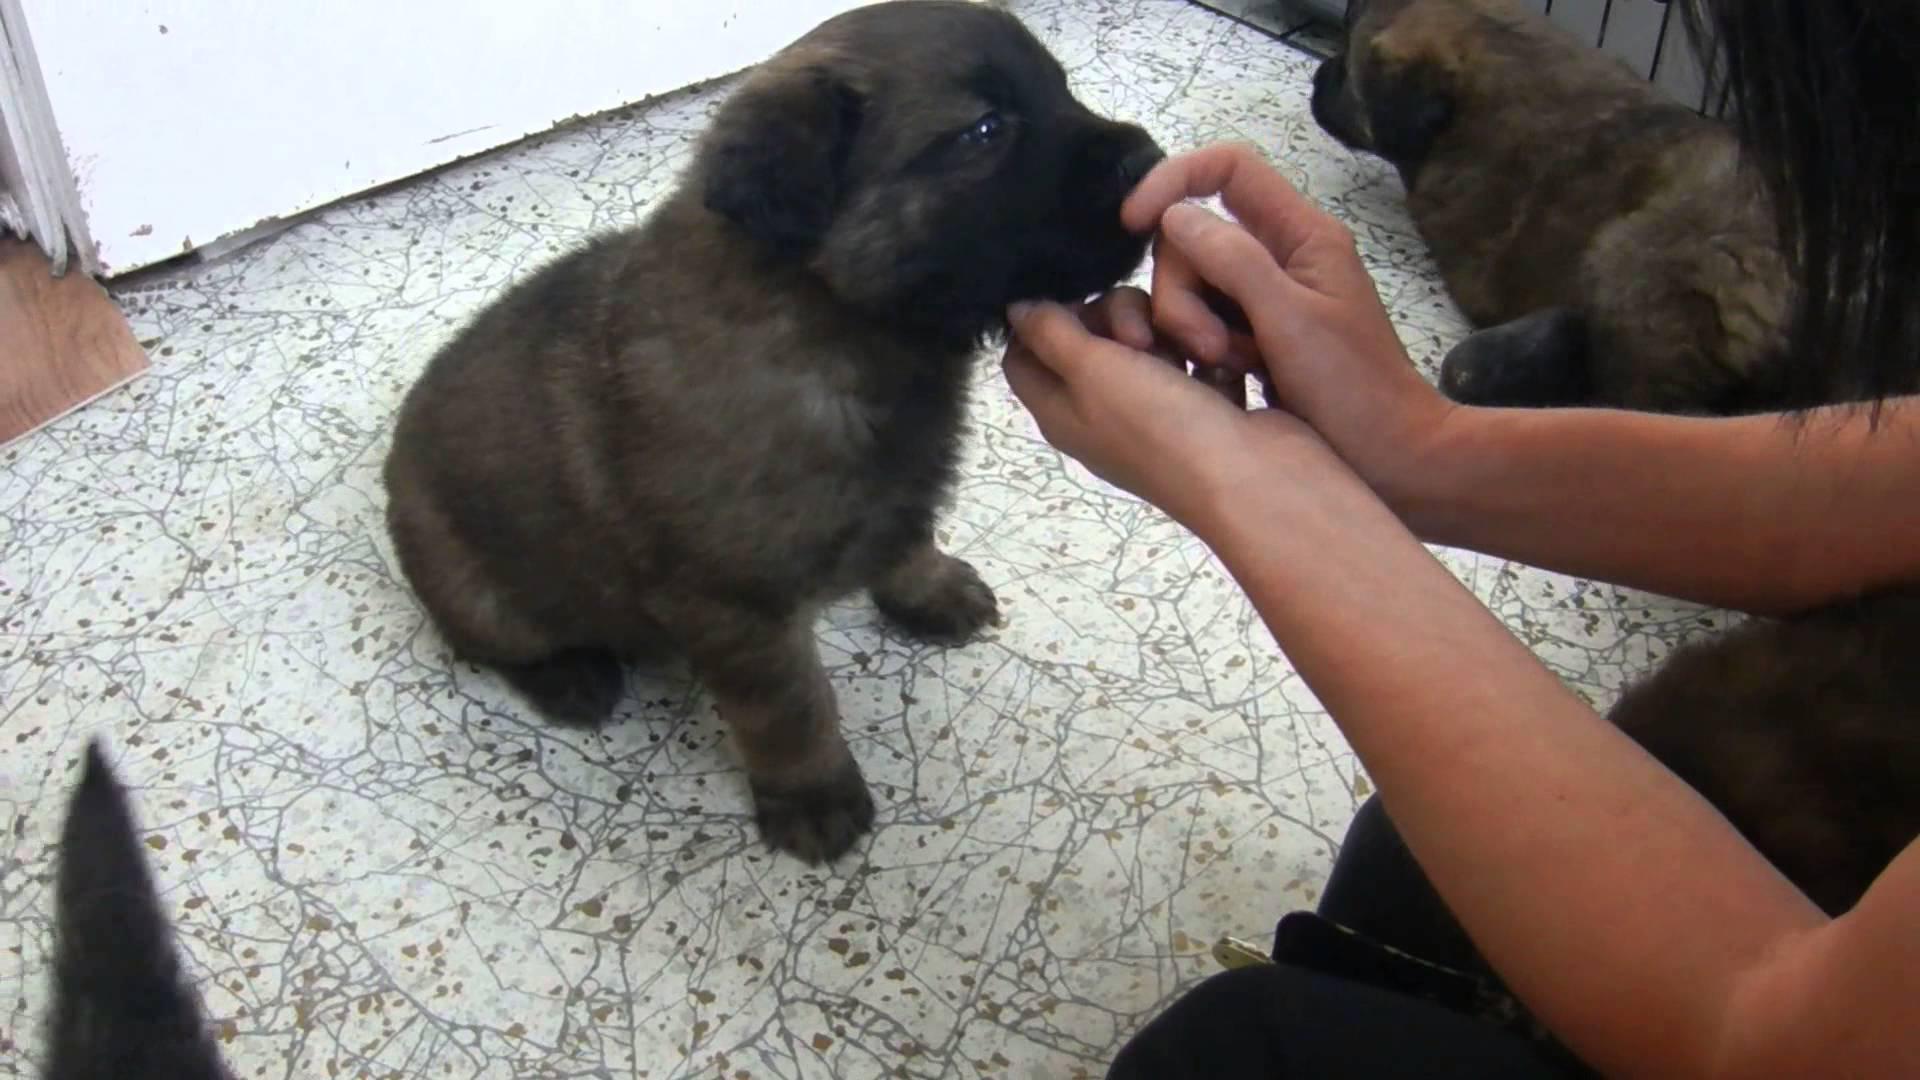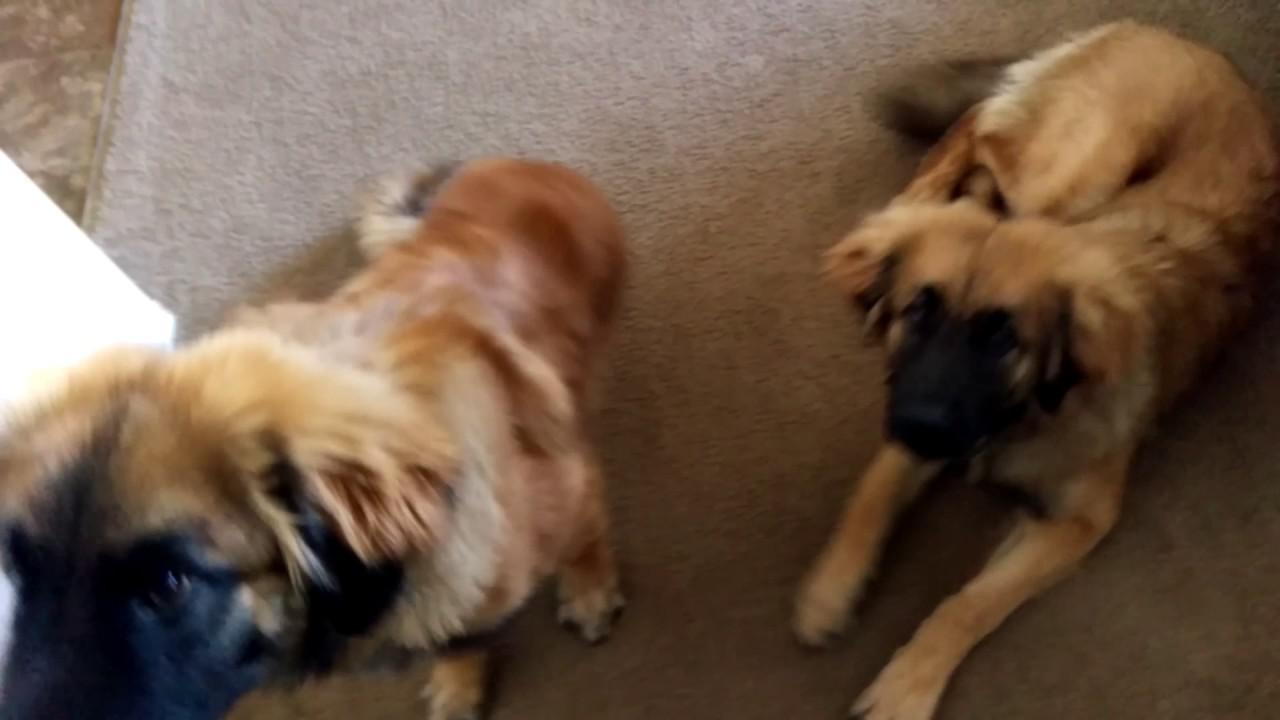The first image is the image on the left, the second image is the image on the right. Assess this claim about the two images: "There is an adult dog chewing on the animal flesh.". Correct or not? Answer yes or no. No. The first image is the image on the left, the second image is the image on the right. Considering the images on both sides, is "The left image shows a reclining big-breed adult dog chewing on some type of raw meat, and the right image shows at least one big-breed puppy." valid? Answer yes or no. No. 